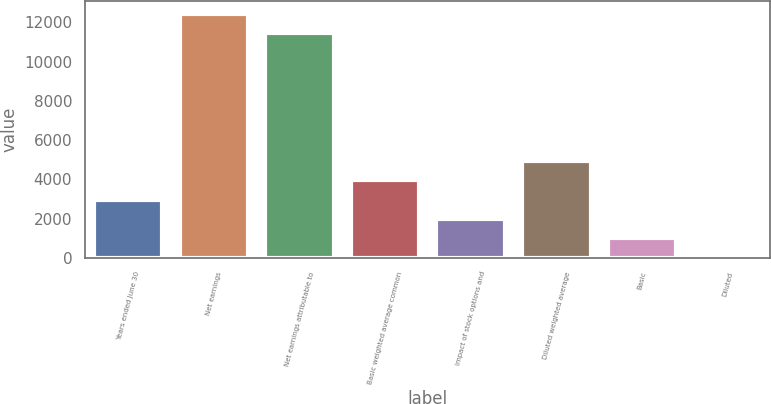<chart> <loc_0><loc_0><loc_500><loc_500><bar_chart><fcel>Years ended June 30<fcel>Net earnings<fcel>Net earnings attributable to<fcel>Basic weighted average common<fcel>Impact of stock options and<fcel>Diluted weighted average<fcel>Basic<fcel>Diluted<nl><fcel>2960.86<fcel>12442.2<fcel>11456.5<fcel>3946.59<fcel>1975.13<fcel>4932.32<fcel>989.4<fcel>3.67<nl></chart> 